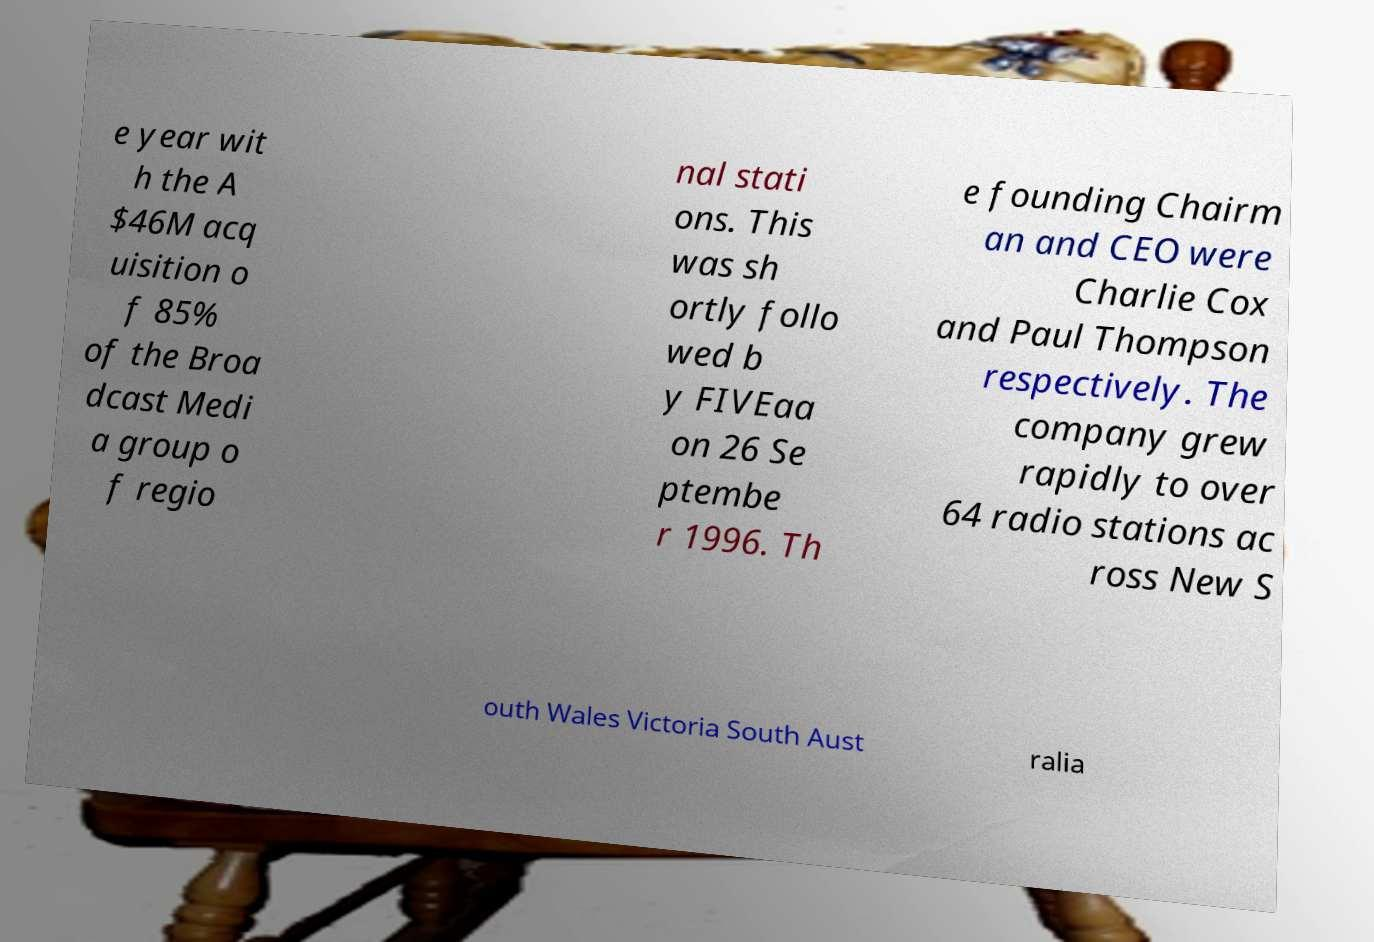Could you assist in decoding the text presented in this image and type it out clearly? e year wit h the A $46M acq uisition o f 85% of the Broa dcast Medi a group o f regio nal stati ons. This was sh ortly follo wed b y FIVEaa on 26 Se ptembe r 1996. Th e founding Chairm an and CEO were Charlie Cox and Paul Thompson respectively. The company grew rapidly to over 64 radio stations ac ross New S outh Wales Victoria South Aust ralia 